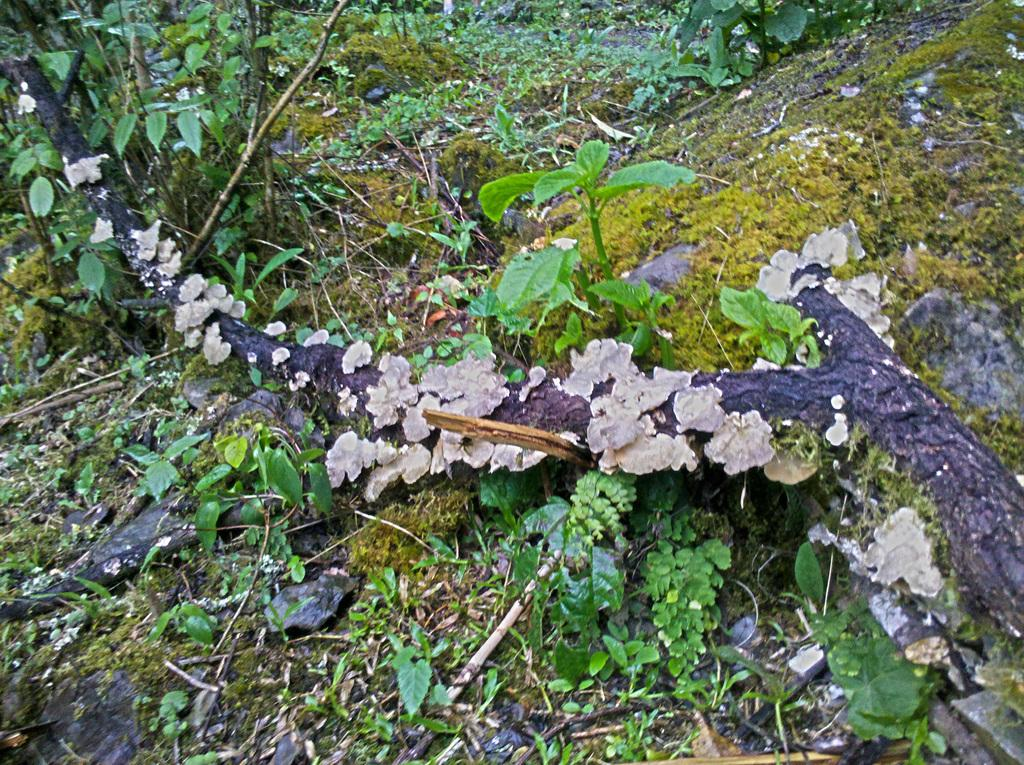What is the main object in the image? There is a fallen tree trunk in the image. What type of vegetation can be seen in the image? There are plants and grass in the image. What is covering the ground in the image? There are leaves on the ground in the image. Where is the bottle floating in the harbor in the image? There is no bottle or harbor present in the image; it features a fallen tree trunk, plants, grass, and leaves on the ground. 